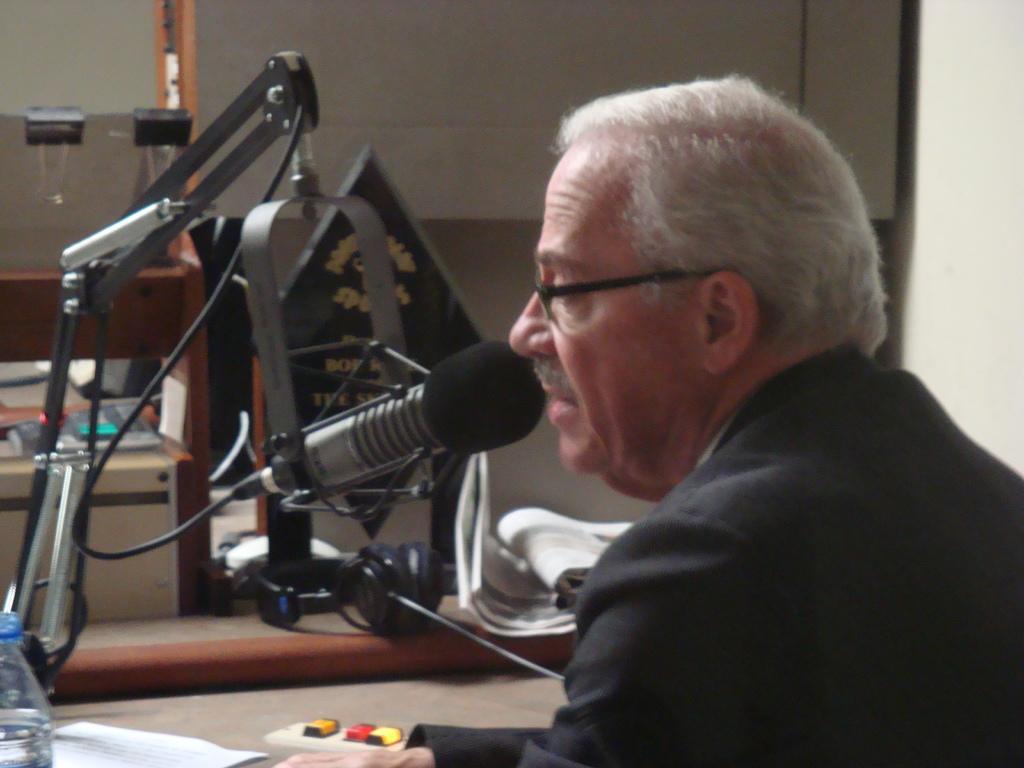Describe this image in one or two sentences. In this image there is a person wearing spectacles. Before him there is a mike stand. Bottom of the image there is a table having bottle, paper and an object. Behind there is a table having headset, paper and few objects on it. Behind it there is an object. Background there is a wall. 